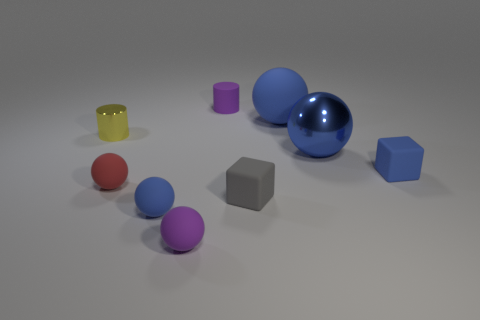Subtract all purple rubber spheres. How many spheres are left? 4 Subtract all cubes. How many objects are left? 7 Subtract all gray blocks. How many blocks are left? 1 Subtract 4 spheres. How many spheres are left? 1 Subtract all brown balls. How many gray blocks are left? 1 Subtract 1 yellow cylinders. How many objects are left? 8 Subtract all gray cylinders. Subtract all brown spheres. How many cylinders are left? 2 Subtract all purple rubber cylinders. Subtract all tiny purple rubber balls. How many objects are left? 7 Add 5 tiny gray objects. How many tiny gray objects are left? 6 Add 2 green cubes. How many green cubes exist? 2 